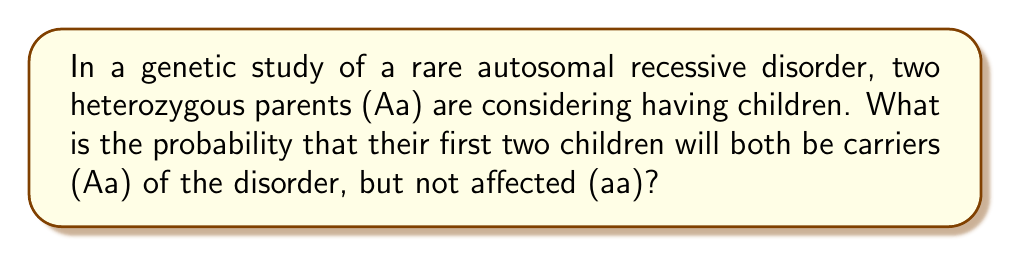Teach me how to tackle this problem. Let's approach this step-by-step:

1) First, recall that for an autosomal recessive disorder:
   - AA = unaffected
   - Aa = carrier (unaffected)
   - aa = affected

2) For heterozygous parents (Aa x Aa), the possible genotypes of their offspring follow the Punnett square:

   $$
   \begin{array}{c|cc}
     & A & a \\
   \hline
   A & AA & Aa \\
   a & Aa & aa
   \end{array}
   $$

3) From this, we can see that the probability of a child being a carrier (Aa) is:

   $P(\text{Aa}) = \frac{2}{4} = \frac{1}{2} = 0.5$ or 50%

4) Now, we need to calculate the probability of this event occurring twice independently (for two children). We use the multiplication rule of probability:

   $P(\text{Both Aa}) = P(\text{Aa}) \times P(\text{Aa}) = \frac{1}{2} \times \frac{1}{2} = \frac{1}{4} = 0.25$

5) Therefore, the probability that their first two children will both be carriers (Aa) is 0.25 or 25%.
Answer: $\frac{1}{4}$ or 0.25 or 25% 